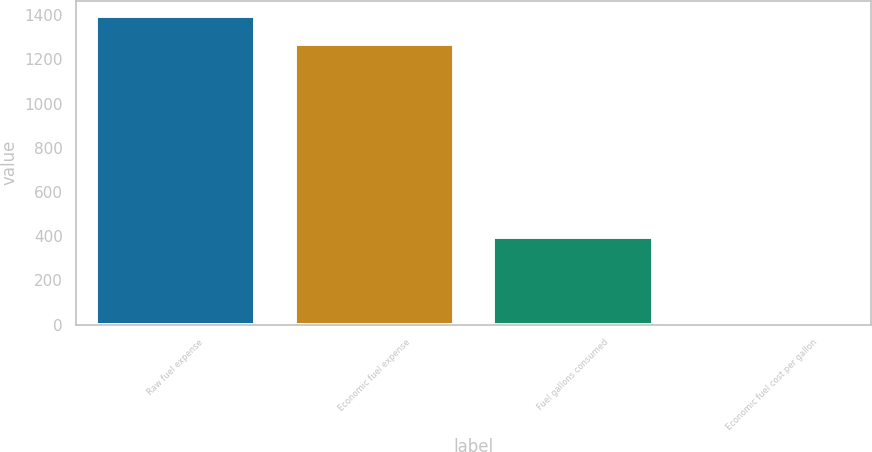Convert chart to OTSL. <chart><loc_0><loc_0><loc_500><loc_500><bar_chart><fcel>Raw fuel expense<fcel>Economic fuel expense<fcel>Fuel gallons consumed<fcel>Economic fuel cost per gallon<nl><fcel>1396.18<fcel>1267.6<fcel>398.3<fcel>3.18<nl></chart> 